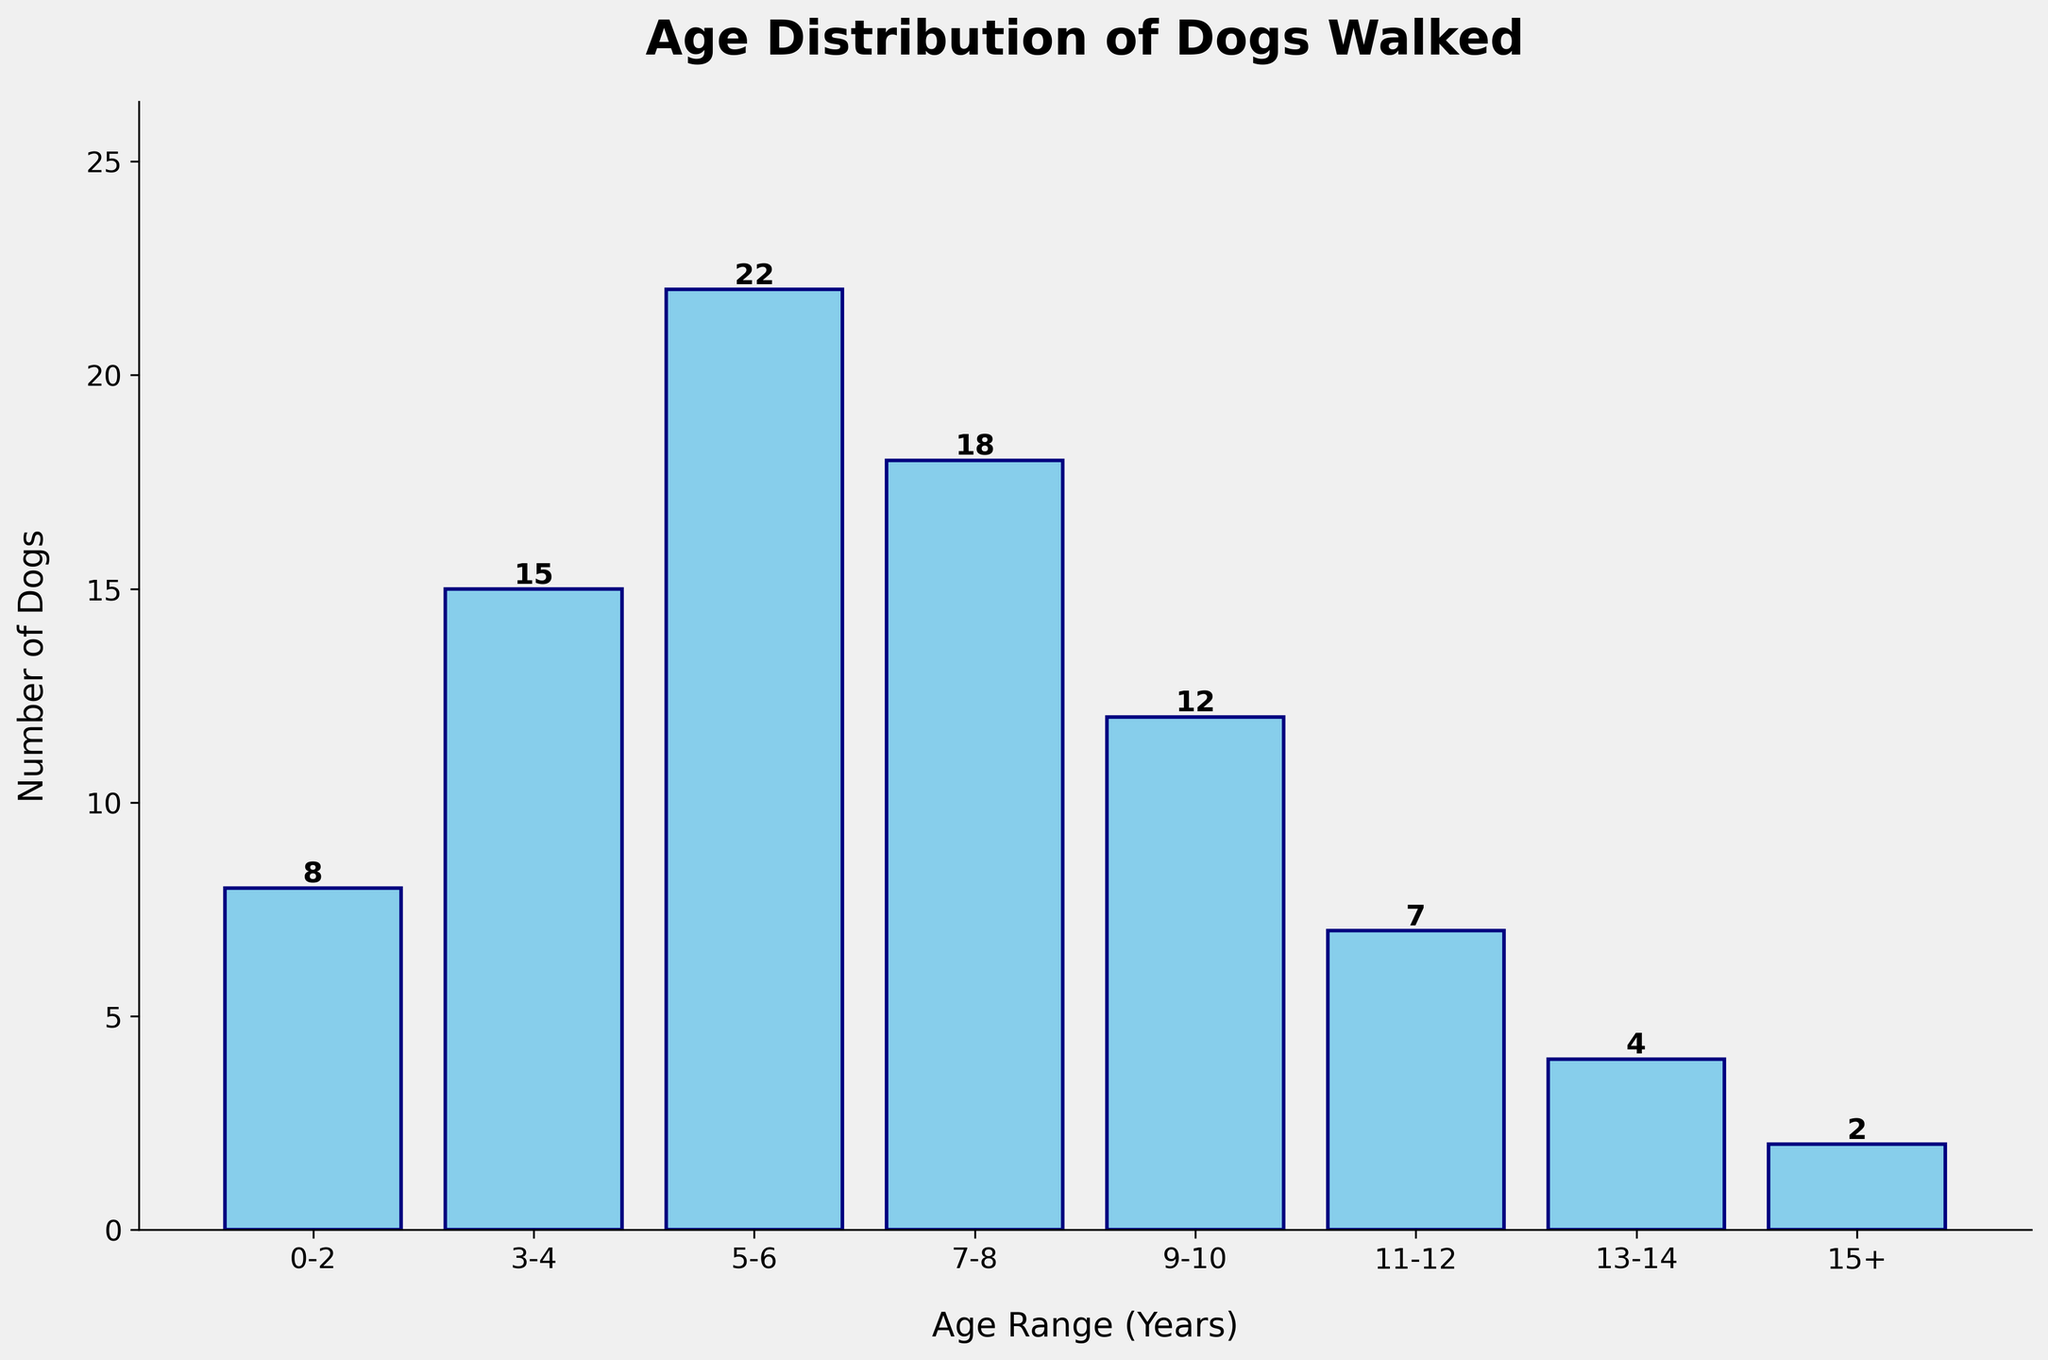What's the title of the plot? The title is a text that appears at the top of the plot, indicating what the plot represents. It summarizes the main content.
Answer: Age Distribution of Dogs Walked What is the age range with the highest number of dogs? To find this, look for the tallest bar in the histogram. The height of the bar represents the number of dogs.
Answer: 5-6 years How many dogs are 0-2 years old? Identify the bar labeled "0-2" on the x-axis and read the height value that is displayed on top of the bar.
Answer: 8 What is the combined number of dogs in the age ranges 9-10 and 11-12? Identify the bars for the "9-10" and "11-12" age ranges and add their heights together. 12 (for 9-10 years) + 7 (for 11-12 years) = 19
Answer: 19 Which age range has fewer dogs, 13-14 or 15+? Compare the heights of the bars labeled "13-14" and "15+". The height of the "13-14" bar is 4, and the height of the "15+" bar is 2.
Answer: 15+ How many dogs are older than 10 years? Add the number of dogs in the bars labeled "11-12", "13-14", and "15+." These bars represent dogs older than 10 years. So, 7 (11-12 years) + 4 (13-14 years) + 2 (15+) = 13.
Answer: 13 What is the total number of dogs walked? Add the heights of all the bars to get the total number of dogs: 8 + 15 + 22 + 18 + 12 + 7 + 4 + 2 = 88.
Answer: 88 Between which age ranges is the largest drop in the number of dogs observed? Compare the differences between the heights of consecutive bars. The largest difference is between the bars "5-6" (22 dogs) and "7-8" (18 dogs), which is 4 dogs.
Answer: 5-6 and 7-8 What is the average number of dogs per age range? Sum the number of dogs and divide by the number of age ranges: Total number of dogs = 88, Number of age ranges = 8. So, 88 / 8 = 11.
Answer: 11 What age range has the second highest number of dogs? The age range with the highest number of dogs is "5-6" with 22 dogs. The second highest is "7-8" with 18 dogs.
Answer: 7-8 years 